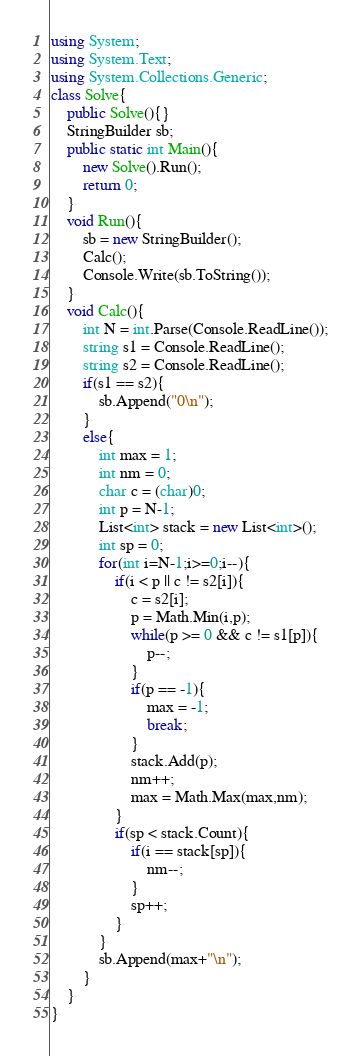Convert code to text. <code><loc_0><loc_0><loc_500><loc_500><_C#_>using System;
using System.Text;
using System.Collections.Generic;
class Solve{
    public Solve(){}
    StringBuilder sb;
    public static int Main(){
        new Solve().Run();
        return 0;
    }
    void Run(){
        sb = new StringBuilder();
        Calc();
        Console.Write(sb.ToString());
    }
    void Calc(){
        int N = int.Parse(Console.ReadLine());
        string s1 = Console.ReadLine();
        string s2 = Console.ReadLine();
        if(s1 == s2){
            sb.Append("0\n");
        }
        else{
            int max = 1;
            int nm = 0;
            char c = (char)0;
            int p = N-1;
            List<int> stack = new List<int>();
            int sp = 0;
            for(int i=N-1;i>=0;i--){
                if(i < p || c != s2[i]){
                    c = s2[i];
                    p = Math.Min(i,p);
                    while(p >= 0 && c != s1[p]){
                        p--;
                    }
                    if(p == -1){
                        max = -1;
                        break;
                    }
                    stack.Add(p);
                    nm++;
                    max = Math.Max(max,nm);
                }
                if(sp < stack.Count){
                    if(i == stack[sp]){
                        nm--;
                    }
                    sp++;
                }
            }
            sb.Append(max+"\n");
        }
    }
}</code> 